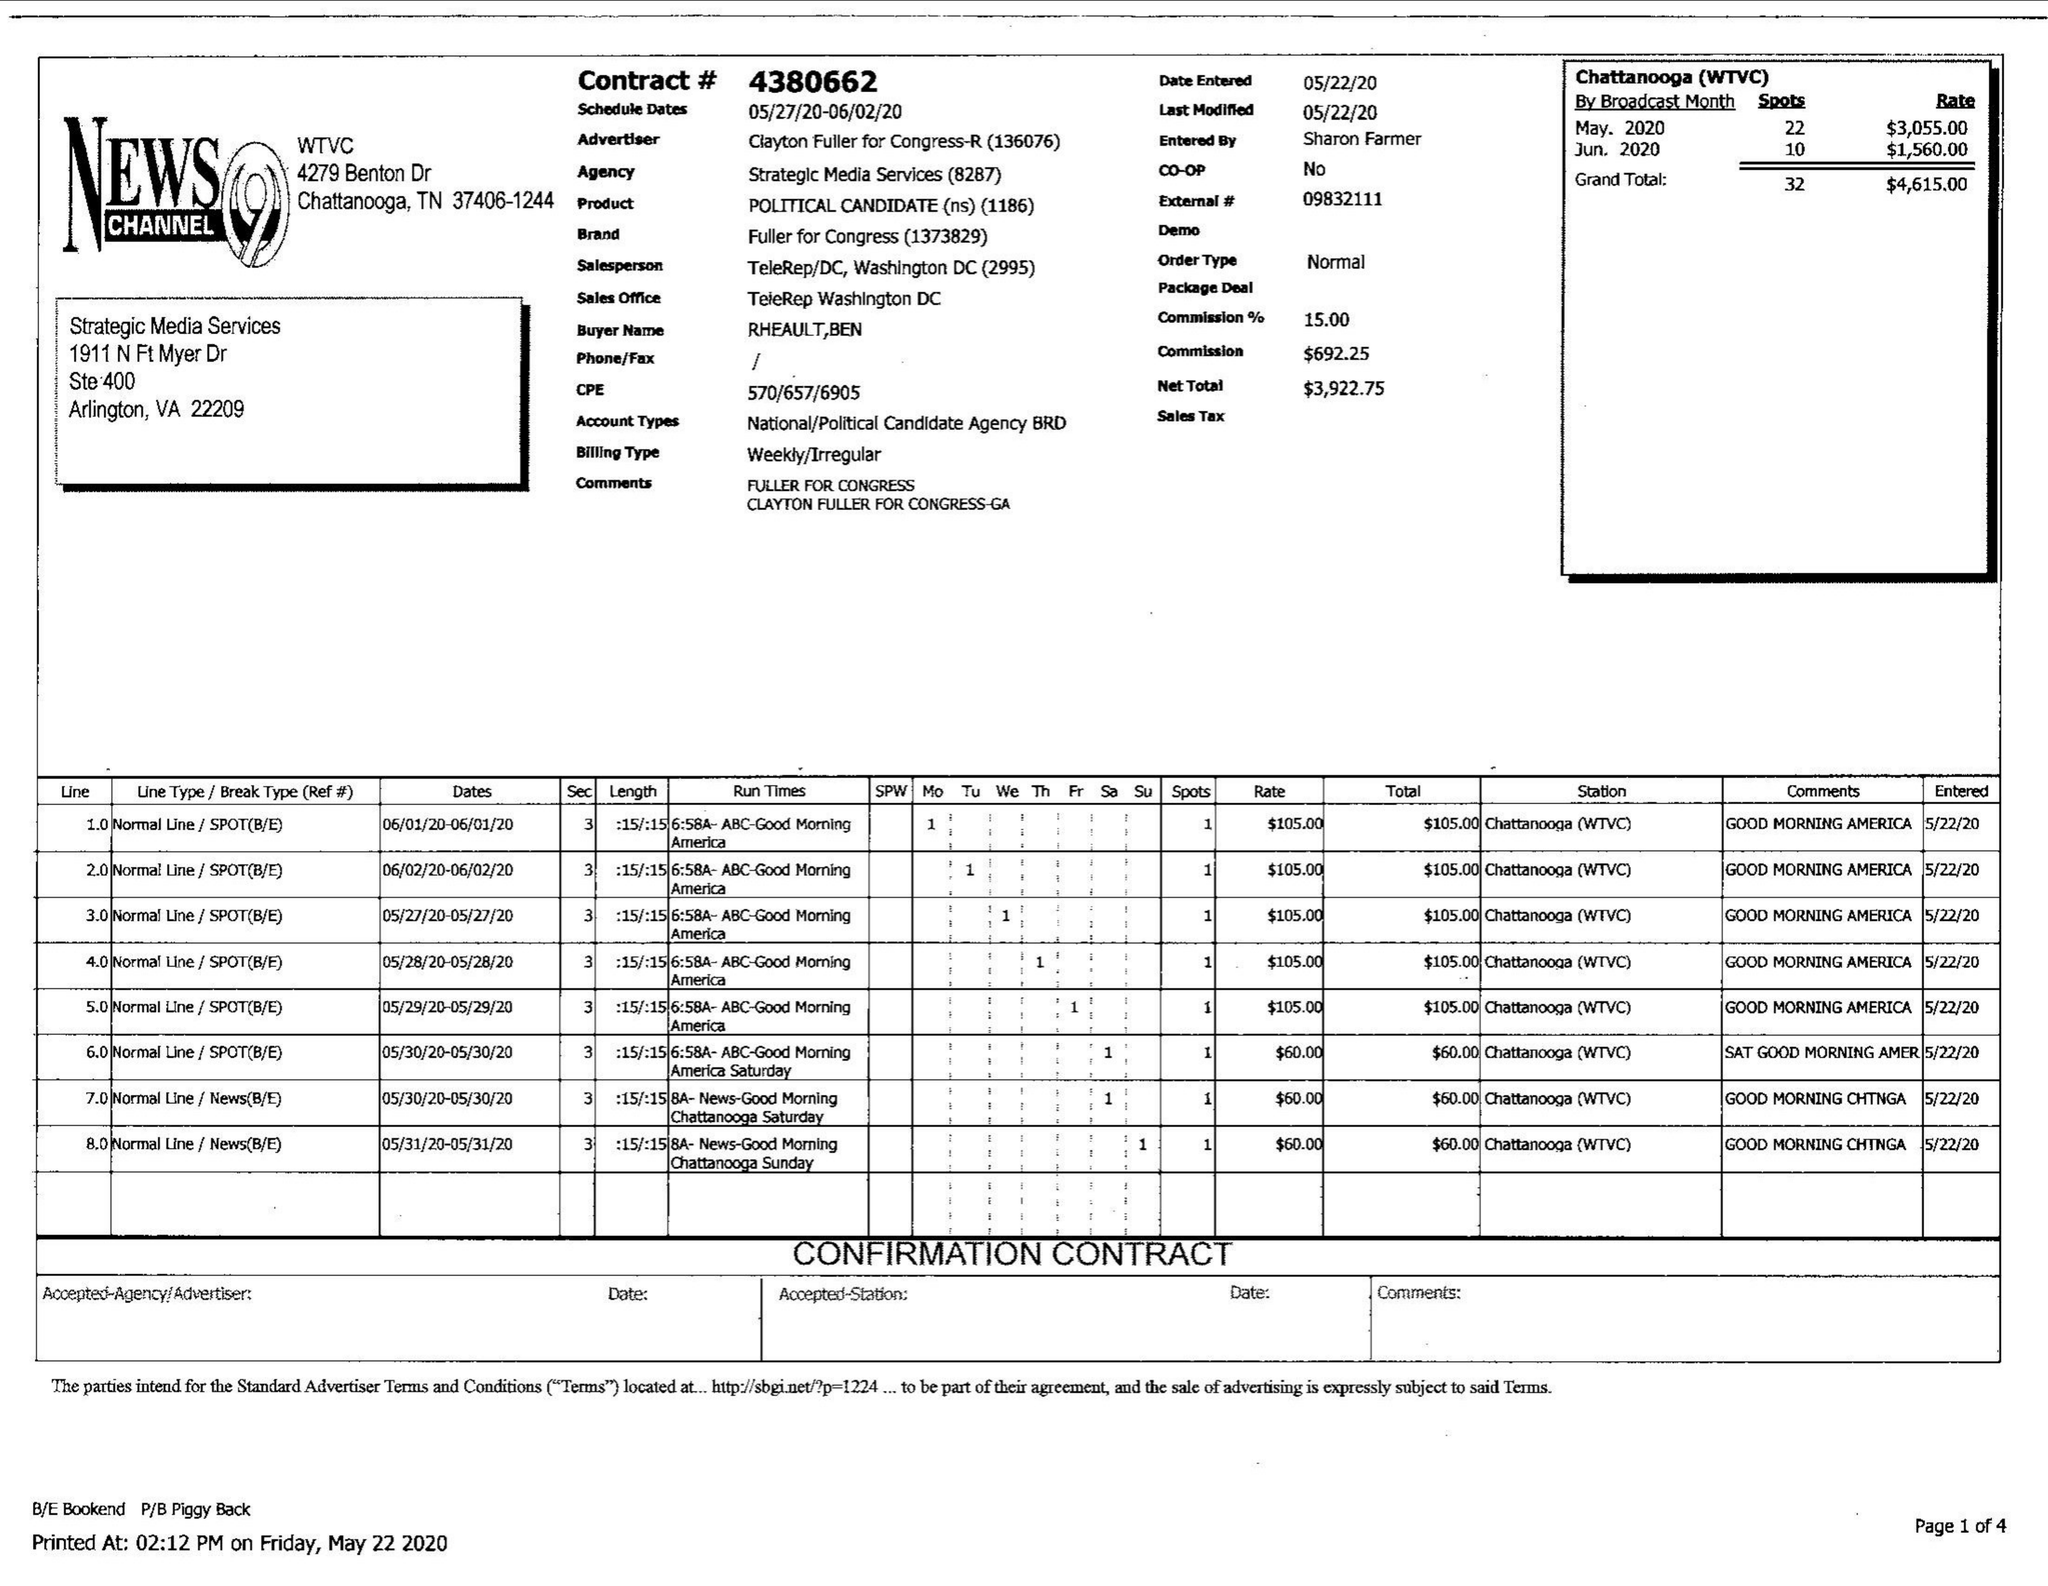What is the value for the advertiser?
Answer the question using a single word or phrase. CLAYTON FULLER FOR CONGRESS-R 